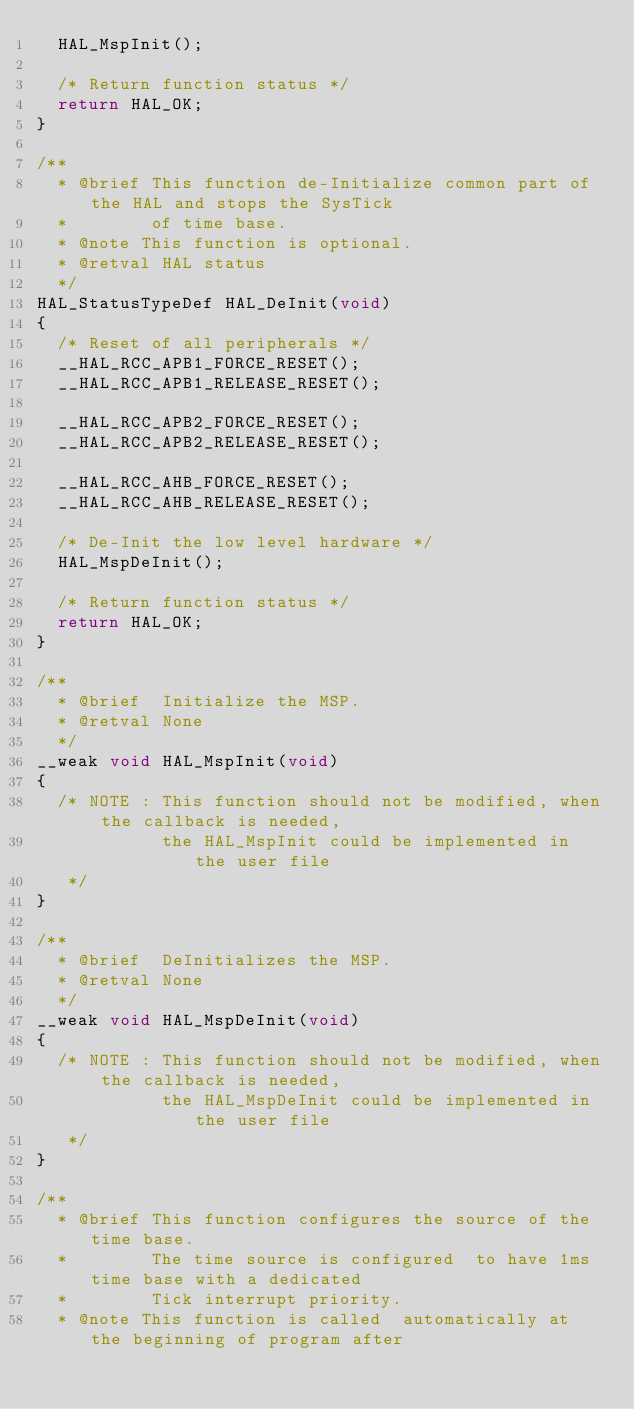Convert code to text. <code><loc_0><loc_0><loc_500><loc_500><_C_>  HAL_MspInit();

  /* Return function status */
  return HAL_OK;
}

/**
  * @brief This function de-Initialize common part of the HAL and stops the SysTick
  *        of time base.
  * @note This function is optional.
  * @retval HAL status
  */
HAL_StatusTypeDef HAL_DeInit(void)
{
  /* Reset of all peripherals */
  __HAL_RCC_APB1_FORCE_RESET();
  __HAL_RCC_APB1_RELEASE_RESET();

  __HAL_RCC_APB2_FORCE_RESET();
  __HAL_RCC_APB2_RELEASE_RESET();

  __HAL_RCC_AHB_FORCE_RESET();
  __HAL_RCC_AHB_RELEASE_RESET();

  /* De-Init the low level hardware */
  HAL_MspDeInit();
    
  /* Return function status */
  return HAL_OK;
}

/**
  * @brief  Initialize the MSP.
  * @retval None
  */
__weak void HAL_MspInit(void)
{
  /* NOTE : This function should not be modified, when the callback is needed,
            the HAL_MspInit could be implemented in the user file
   */
}

/**
  * @brief  DeInitializes the MSP.
  * @retval None
  */
__weak void HAL_MspDeInit(void)
{
  /* NOTE : This function should not be modified, when the callback is needed,
            the HAL_MspDeInit could be implemented in the user file
   */
}

/**
  * @brief This function configures the source of the time base. 
  *        The time source is configured  to have 1ms time base with a dedicated 
  *        Tick interrupt priority.
  * @note This function is called  automatically at the beginning of program after</code> 